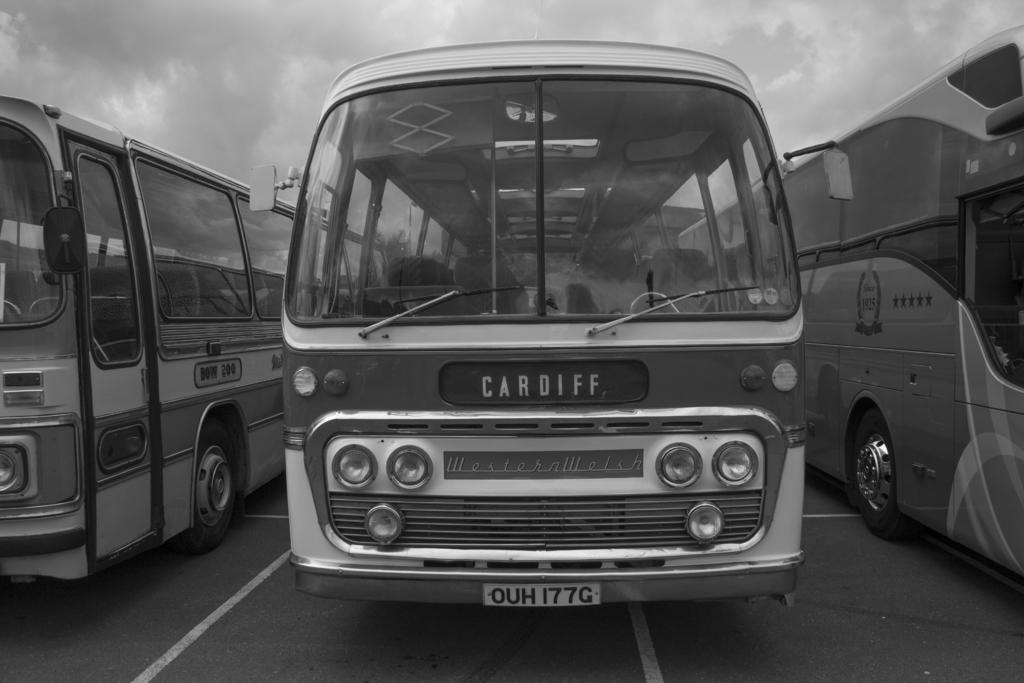<image>
Describe the image concisely. A black and white photo of three old busses the middle one of which is face on and has Cardiff as its destination. 